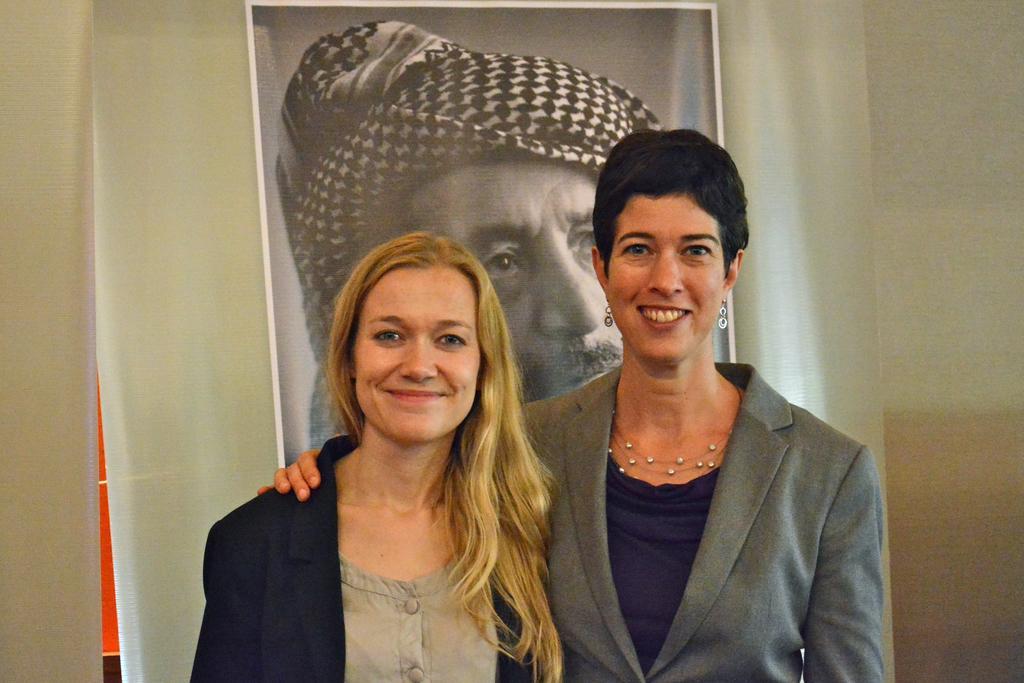Describe this image in one or two sentences. In this image we can see two women smiling. In the background we can see some persons banner and we can also see the plain wall. 